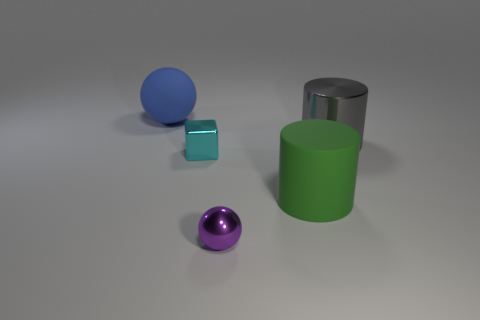Add 2 big blue rubber things. How many objects exist? 7 Subtract all cylinders. How many objects are left? 3 Add 1 tiny blocks. How many tiny blocks are left? 2 Add 5 green matte objects. How many green matte objects exist? 6 Subtract 1 blue balls. How many objects are left? 4 Subtract all gray metal things. Subtract all gray shiny objects. How many objects are left? 3 